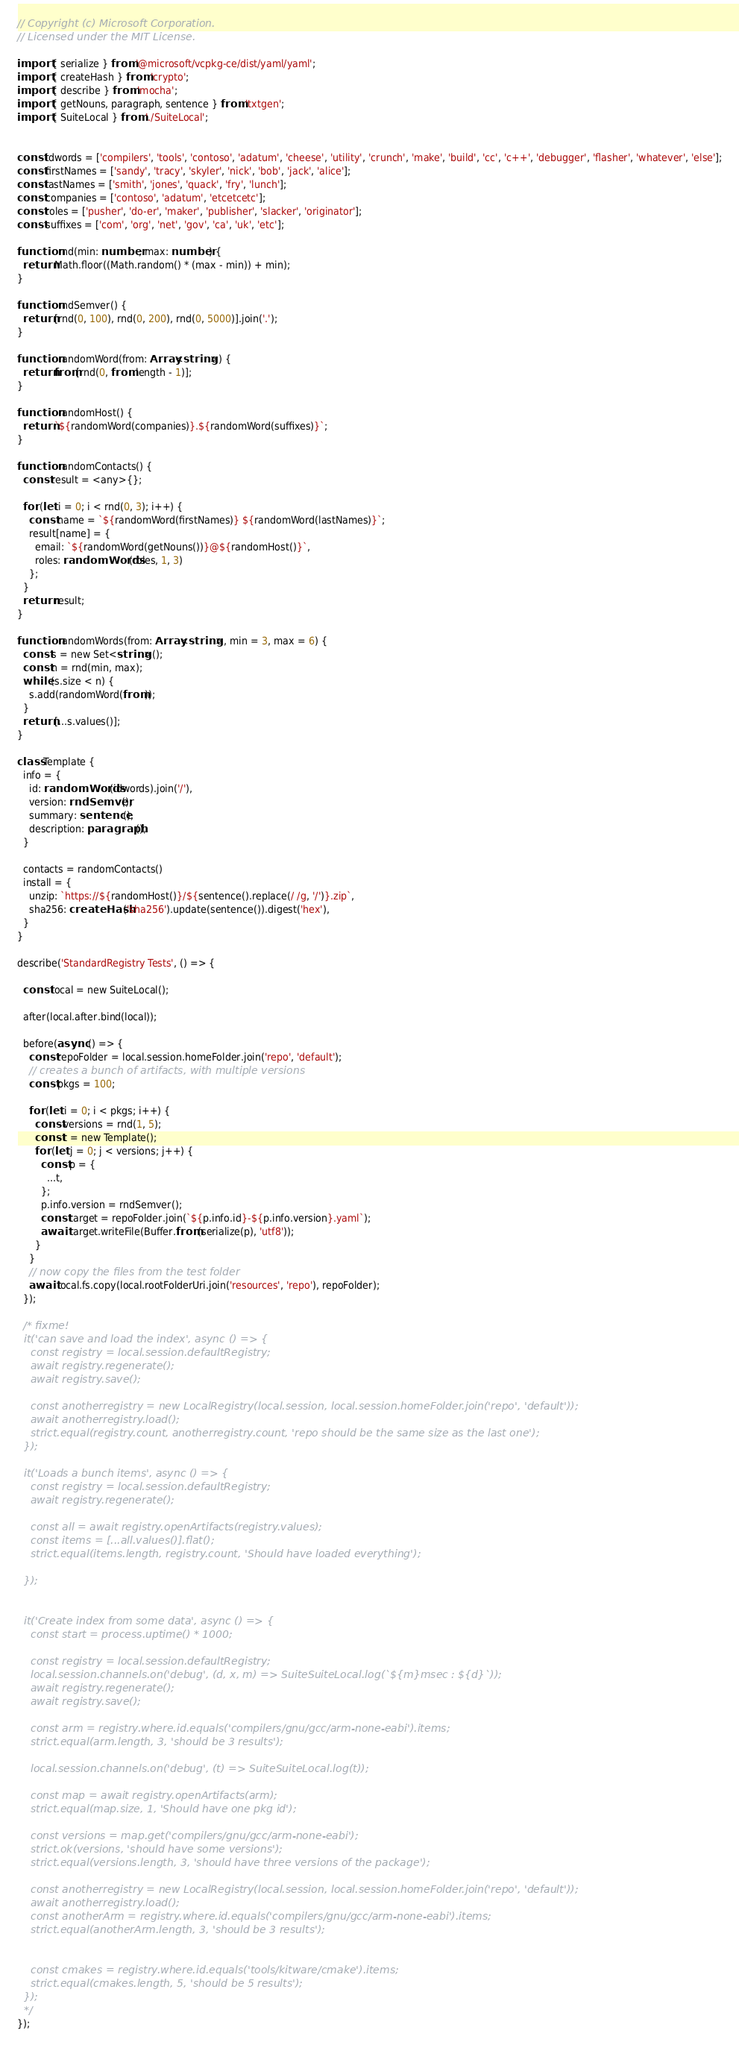Convert code to text. <code><loc_0><loc_0><loc_500><loc_500><_TypeScript_>// Copyright (c) Microsoft Corporation.
// Licensed under the MIT License.

import { serialize } from '@microsoft/vcpkg-ce/dist/yaml/yaml';
import { createHash } from 'crypto';
import { describe } from 'mocha';
import { getNouns, paragraph, sentence } from 'txtgen';
import { SuiteLocal } from './SuiteLocal';


const idwords = ['compilers', 'tools', 'contoso', 'adatum', 'cheese', 'utility', 'crunch', 'make', 'build', 'cc', 'c++', 'debugger', 'flasher', 'whatever', 'else'];
const firstNames = ['sandy', 'tracy', 'skyler', 'nick', 'bob', 'jack', 'alice'];
const lastNames = ['smith', 'jones', 'quack', 'fry', 'lunch'];
const companies = ['contoso', 'adatum', 'etcetcetc'];
const roles = ['pusher', 'do-er', 'maker', 'publisher', 'slacker', 'originator'];
const suffixes = ['com', 'org', 'net', 'gov', 'ca', 'uk', 'etc'];

function rnd(min: number, max: number) {
  return Math.floor((Math.random() * (max - min)) + min);
}

function rndSemver() {
  return [rnd(0, 100), rnd(0, 200), rnd(0, 5000)].join('.');
}

function randomWord(from: Array<string>) {
  return from[rnd(0, from.length - 1)];
}

function randomHost() {
  return `${randomWord(companies)}.${randomWord(suffixes)}`;
}

function randomContacts() {
  const result = <any>{};

  for (let i = 0; i < rnd(0, 3); i++) {
    const name = `${randomWord(firstNames)} ${randomWord(lastNames)}`;
    result[name] = {
      email: `${randomWord(getNouns())}@${randomHost()}`,
      roles: randomWords(roles, 1, 3)
    };
  }
  return result;
}

function randomWords(from: Array<string>, min = 3, max = 6) {
  const s = new Set<string>();
  const n = rnd(min, max);
  while (s.size < n) {
    s.add(randomWord(from));
  }
  return [...s.values()];
}

class Template {
  info = {
    id: randomWords(idwords).join('/'),
    version: rndSemver(),
    summary: sentence(),
    description: paragraph(),
  }

  contacts = randomContacts()
  install = {
    unzip: `https://${randomHost()}/${sentence().replace(/ /g, '/')}.zip`,
    sha256: createHash('sha256').update(sentence()).digest('hex'),
  }
}

describe('StandardRegistry Tests', () => {

  const local = new SuiteLocal();

  after(local.after.bind(local));

  before(async () => {
    const repoFolder = local.session.homeFolder.join('repo', 'default');
    // creates a bunch of artifacts, with multiple versions
    const pkgs = 100;

    for (let i = 0; i < pkgs; i++) {
      const versions = rnd(1, 5);
      const t = new Template();
      for (let j = 0; j < versions; j++) {
        const p = {
          ...t,
        };
        p.info.version = rndSemver();
        const target = repoFolder.join(`${p.info.id}-${p.info.version}.yaml`);
        await target.writeFile(Buffer.from(serialize(p), 'utf8'));
      }
    }
    // now copy the files from the test folder
    await local.fs.copy(local.rootFolderUri.join('resources', 'repo'), repoFolder);
  });

  /* fixme!
  it('can save and load the index', async () => {
    const registry = local.session.defaultRegistry;
    await registry.regenerate();
    await registry.save();

    const anotherregistry = new LocalRegistry(local.session, local.session.homeFolder.join('repo', 'default'));
    await anotherregistry.load();
    strict.equal(registry.count, anotherregistry.count, 'repo should be the same size as the last one');
  });

  it('Loads a bunch items', async () => {
    const registry = local.session.defaultRegistry;
    await registry.regenerate();

    const all = await registry.openArtifacts(registry.values);
    const items = [...all.values()].flat();
    strict.equal(items.length, registry.count, 'Should have loaded everything');

  });


  it('Create index from some data', async () => {
    const start = process.uptime() * 1000;

    const registry = local.session.defaultRegistry;
    local.session.channels.on('debug', (d, x, m) => SuiteSuiteLocal.log(`${m}msec : ${d}`));
    await registry.regenerate();
    await registry.save();

    const arm = registry.where.id.equals('compilers/gnu/gcc/arm-none-eabi').items;
    strict.equal(arm.length, 3, 'should be 3 results');

    local.session.channels.on('debug', (t) => SuiteSuiteLocal.log(t));

    const map = await registry.openArtifacts(arm);
    strict.equal(map.size, 1, 'Should have one pkg id');

    const versions = map.get('compilers/gnu/gcc/arm-none-eabi');
    strict.ok(versions, 'should have some versions');
    strict.equal(versions.length, 3, 'should have three versions of the package');

    const anotherregistry = new LocalRegistry(local.session, local.session.homeFolder.join('repo', 'default'));
    await anotherregistry.load();
    const anotherArm = registry.where.id.equals('compilers/gnu/gcc/arm-none-eabi').items;
    strict.equal(anotherArm.length, 3, 'should be 3 results');


    const cmakes = registry.where.id.equals('tools/kitware/cmake').items;
    strict.equal(cmakes.length, 5, 'should be 5 results');
  });
  */
});</code> 